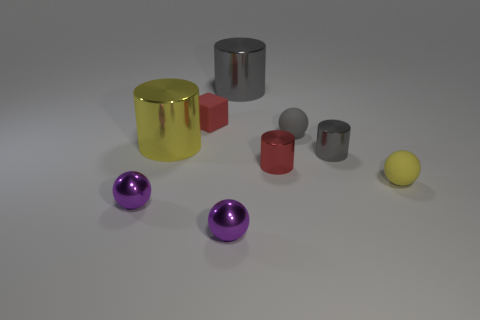How many shiny cylinders are there?
Make the answer very short. 4. There is a big object that is behind the sphere that is behind the tiny red shiny cylinder; what is its material?
Provide a succinct answer. Metal. There is a yellow thing that is the same size as the cube; what is it made of?
Your response must be concise. Rubber. There is a ball that is to the left of the red block; is it the same size as the tiny gray matte sphere?
Offer a very short reply. Yes. There is a yellow thing in front of the tiny gray shiny thing; is its shape the same as the big yellow metal thing?
Your answer should be very brief. No. How many things are purple spheres or small gray objects that are to the left of the tiny gray cylinder?
Offer a terse response. 3. Are there fewer tiny brown metallic cylinders than purple metallic objects?
Your answer should be compact. Yes. Is the number of small gray matte spheres greater than the number of small gray things?
Keep it short and to the point. No. How many other things are made of the same material as the tiny red cylinder?
Ensure brevity in your answer.  5. There is a matte thing behind the tiny sphere behind the tiny red cylinder; what number of metallic balls are to the left of it?
Make the answer very short. 1. 